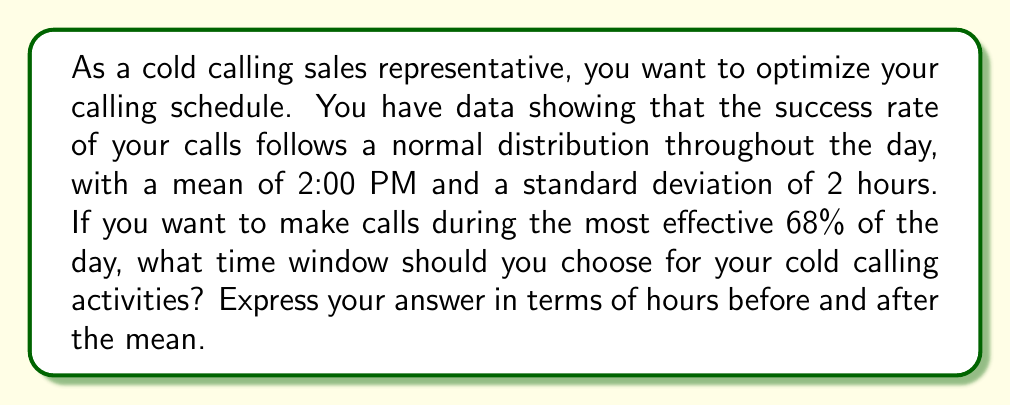Teach me how to tackle this problem. To solve this problem, we need to use properties of the normal distribution and the concept of standard deviations. Let's break it down step-by-step:

1) The normal distribution has a key property: approximately 68% of the data falls within one standard deviation of the mean.

2) Given:
   - Mean (μ) = 2:00 PM
   - Standard deviation (σ) = 2 hours
   - We want the most effective 68% of the day

3) Since 68% of the data falls within one standard deviation of the mean in a normal distribution, we need to calculate the time range that is ±1σ from the mean.

4) The time window will be:
   $$(μ - 1σ) \text{ to } (μ + 1σ)$$

5) Substituting our values:
   $$(2:00\text{ PM} - 2\text{ hours}) \text{ to } (2:00\text{ PM} + 2\text{ hours})$$

6) This gives us a time window of:
   12:00 PM to 4:00 PM

7) To express this in terms of hours before and after the mean:
   2 hours before 2:00 PM to 2 hours after 2:00 PM

Therefore, the optimal time window for cold calling is from 2 hours before the mean time to 2 hours after the mean time.
Answer: ±2 hours from 2:00 PM 